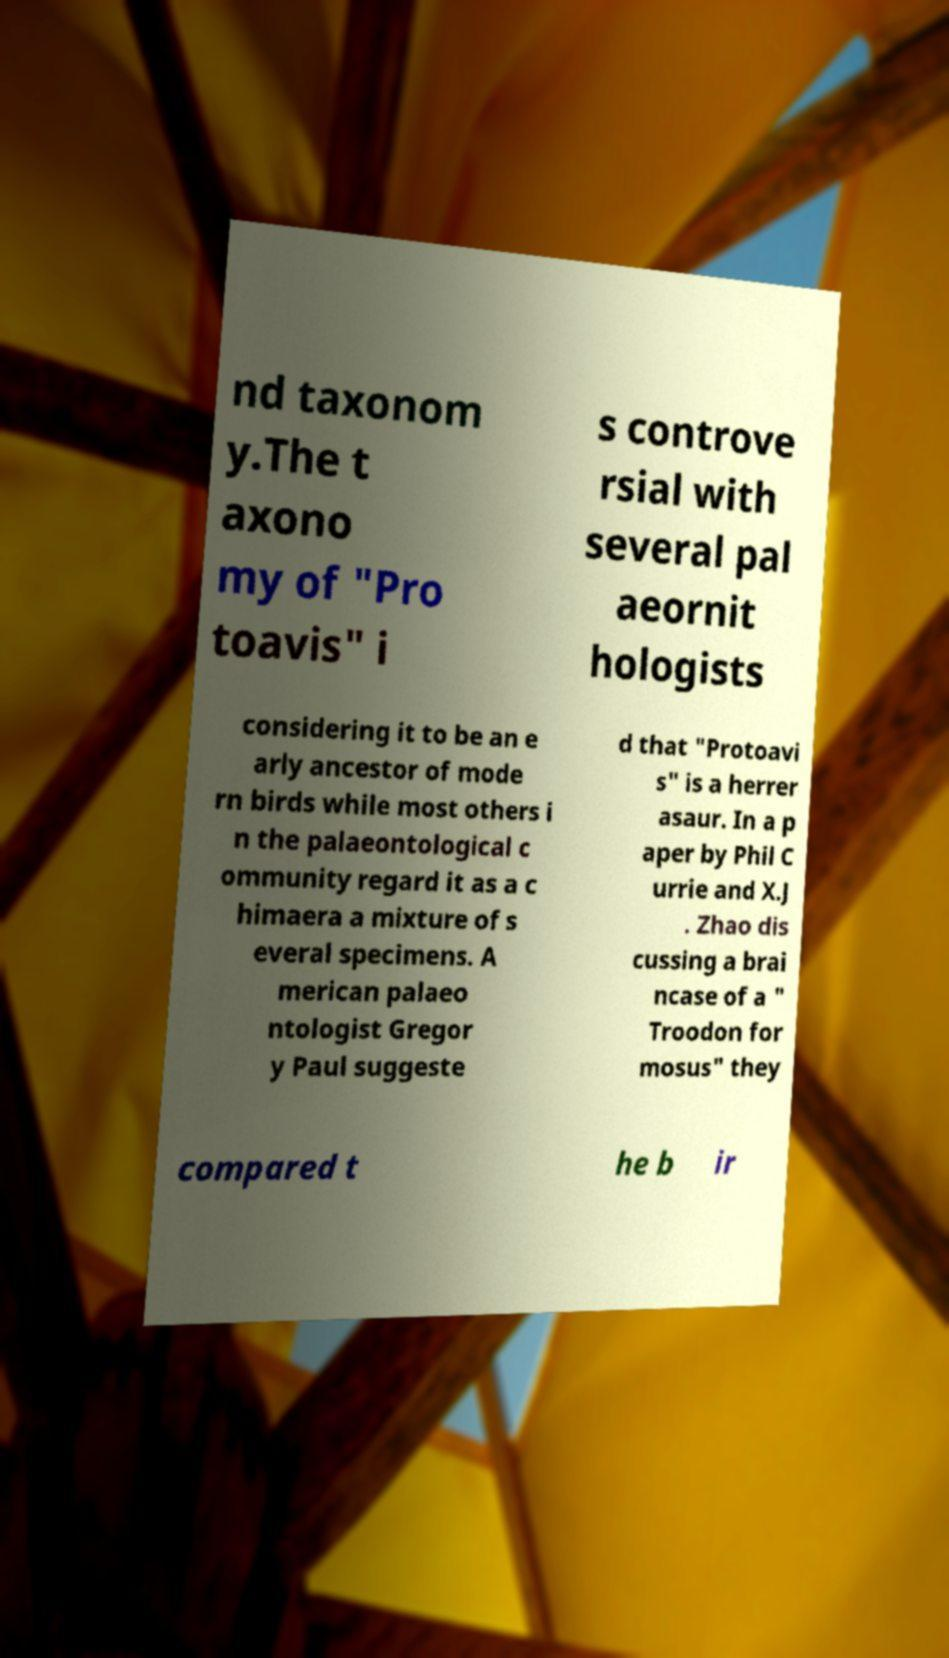There's text embedded in this image that I need extracted. Can you transcribe it verbatim? nd taxonom y.The t axono my of "Pro toavis" i s controve rsial with several pal aeornit hologists considering it to be an e arly ancestor of mode rn birds while most others i n the palaeontological c ommunity regard it as a c himaera a mixture of s everal specimens. A merican palaeo ntologist Gregor y Paul suggeste d that "Protoavi s" is a herrer asaur. In a p aper by Phil C urrie and X.J . Zhao dis cussing a brai ncase of a " Troodon for mosus" they compared t he b ir 